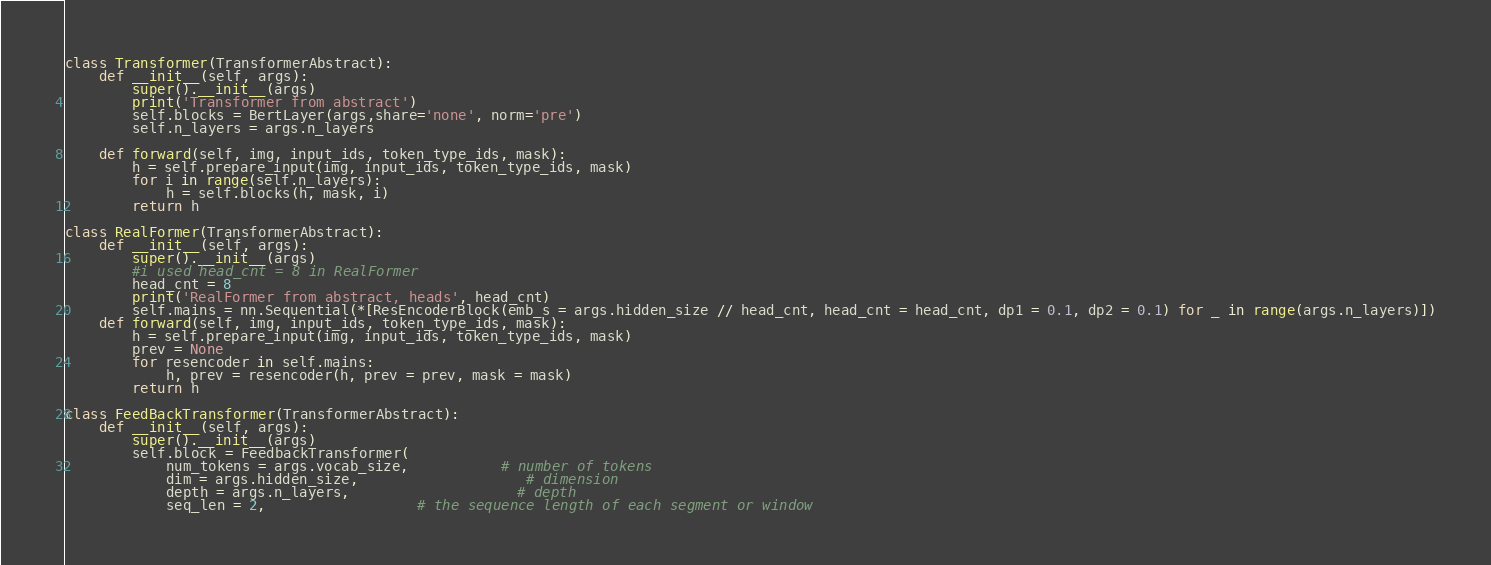Convert code to text. <code><loc_0><loc_0><loc_500><loc_500><_Python_>class Transformer(TransformerAbstract):
    def __init__(self, args):
        super().__init__(args)
        print('Transformer from abstract')
        self.blocks = BertLayer(args,share='none', norm='pre')
        self.n_layers = args.n_layers

    def forward(self, img, input_ids, token_type_ids, mask):
        h = self.prepare_input(img, input_ids, token_type_ids, mask)
        for i in range(self.n_layers):
            h = self.blocks(h, mask, i)
        return h

class RealFormer(TransformerAbstract):
    def __init__(self, args):
        super().__init__(args)
        #i used head_cnt = 8 in RealFormer
        head_cnt = 8
        print('RealFormer from abstract, heads', head_cnt)
        self.mains = nn.Sequential(*[ResEncoderBlock(emb_s = args.hidden_size // head_cnt, head_cnt = head_cnt, dp1 = 0.1, dp2 = 0.1) for _ in range(args.n_layers)])
    def forward(self, img, input_ids, token_type_ids, mask):
        h = self.prepare_input(img, input_ids, token_type_ids, mask)
        prev = None
        for resencoder in self.mains:
            h, prev = resencoder(h, prev = prev, mask = mask)
        return h

class FeedBackTransformer(TransformerAbstract):
    def __init__(self, args):
        super().__init__(args)
        self.block = FeedbackTransformer(
            num_tokens = args.vocab_size,           # number of tokens
            dim = args.hidden_size,                    # dimension
            depth = args.n_layers,                    # depth
            seq_len = 2,                  # the sequence length of each segment or window</code> 